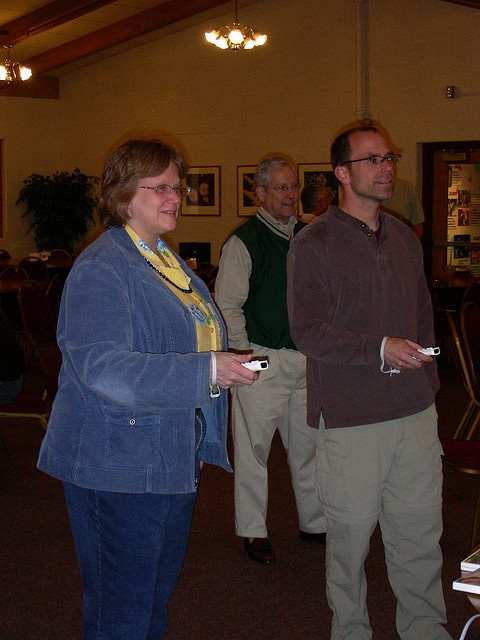Describe the objects in this image and their specific colors. I can see people in maroon, navy, black, darkblue, and gray tones, people in maroon, black, gray, and brown tones, people in maroon, gray, and black tones, potted plant in black and maroon tones, and chair in maroon, black, olive, and gray tones in this image. 